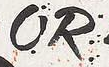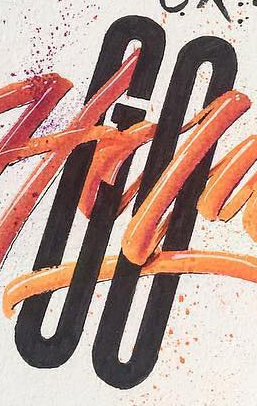Read the text from these images in sequence, separated by a semicolon. OR; GO 